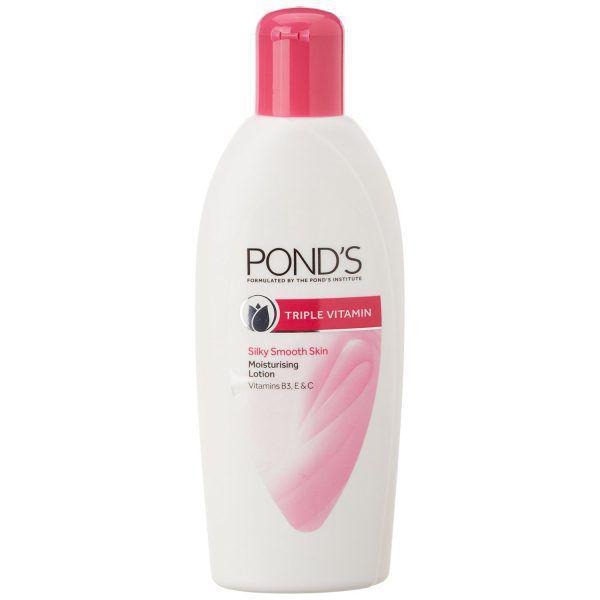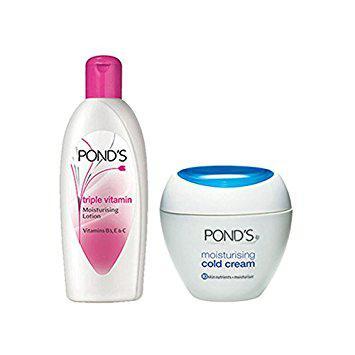The first image is the image on the left, the second image is the image on the right. Examine the images to the left and right. Is the description "There are not more than two different products and they are all made by Ponds." accurate? Answer yes or no. Yes. 